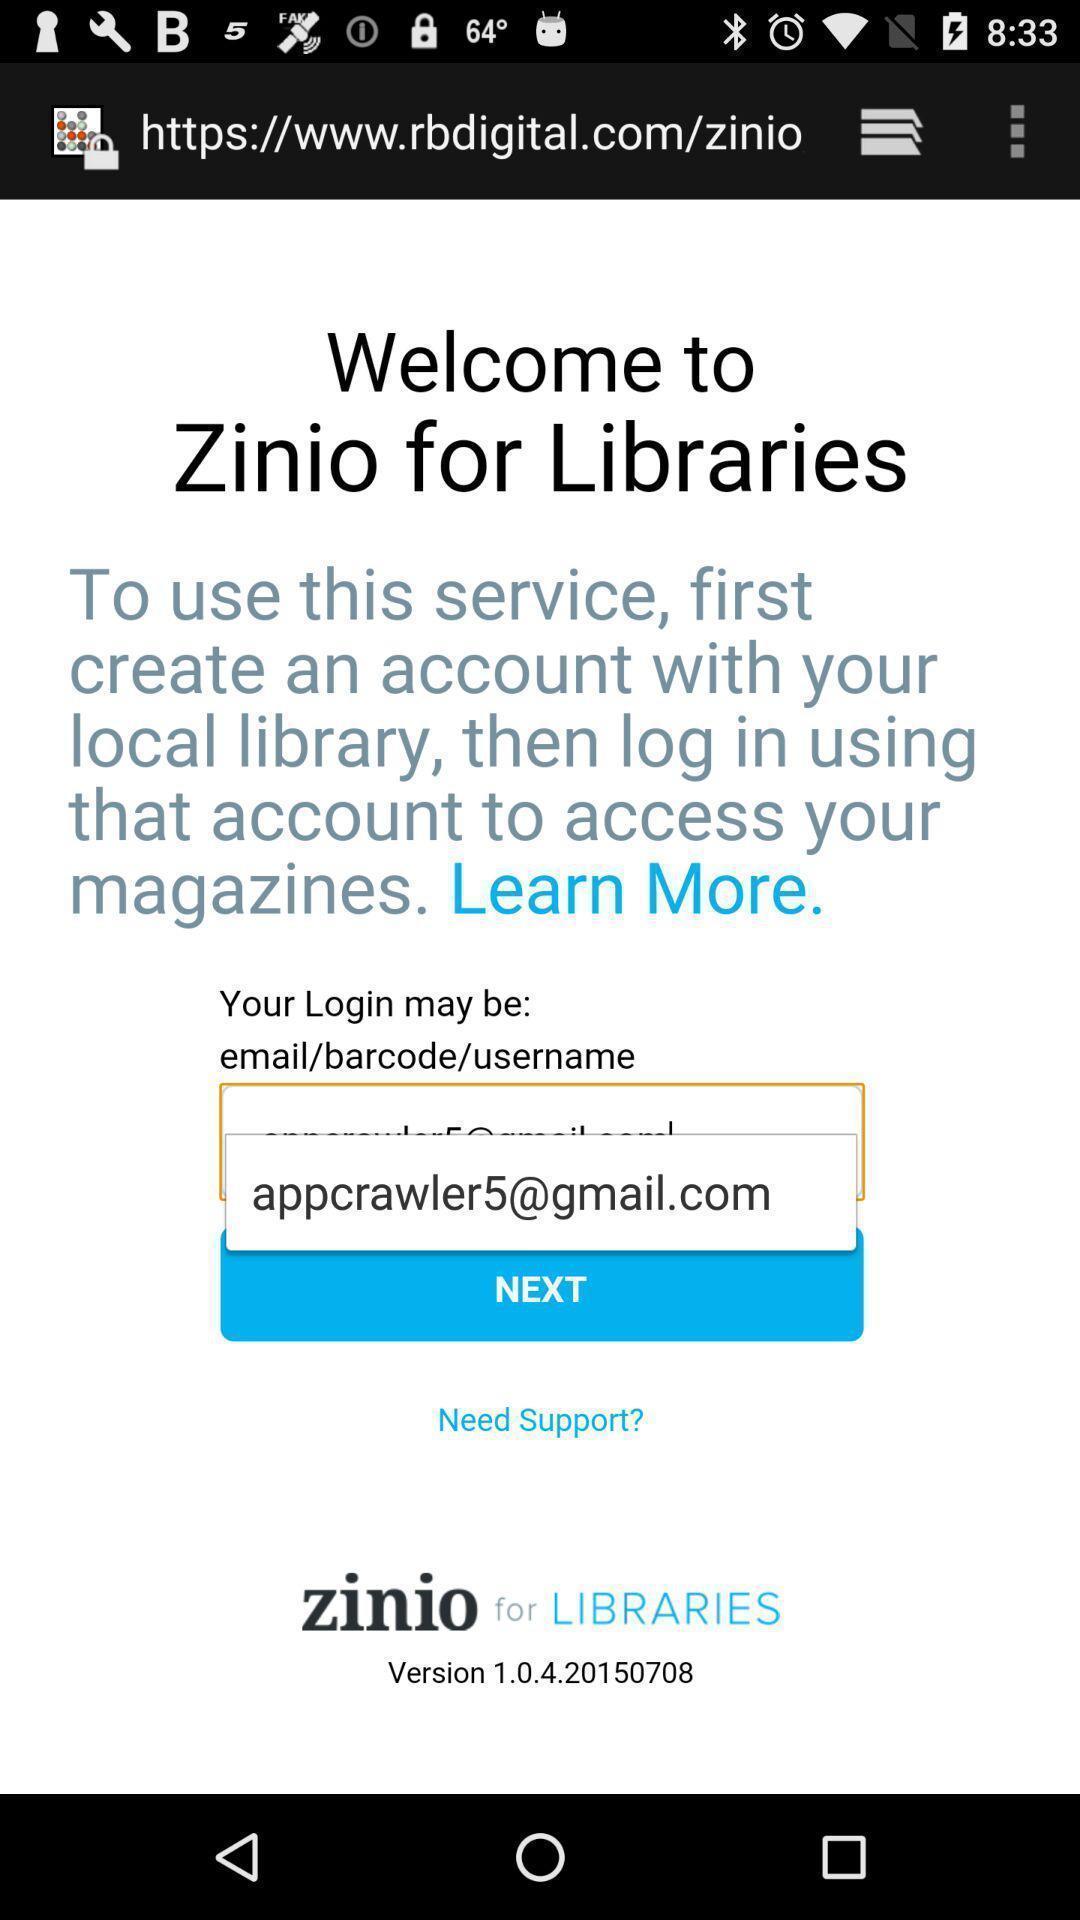Give me a summary of this screen capture. Welcome page. 